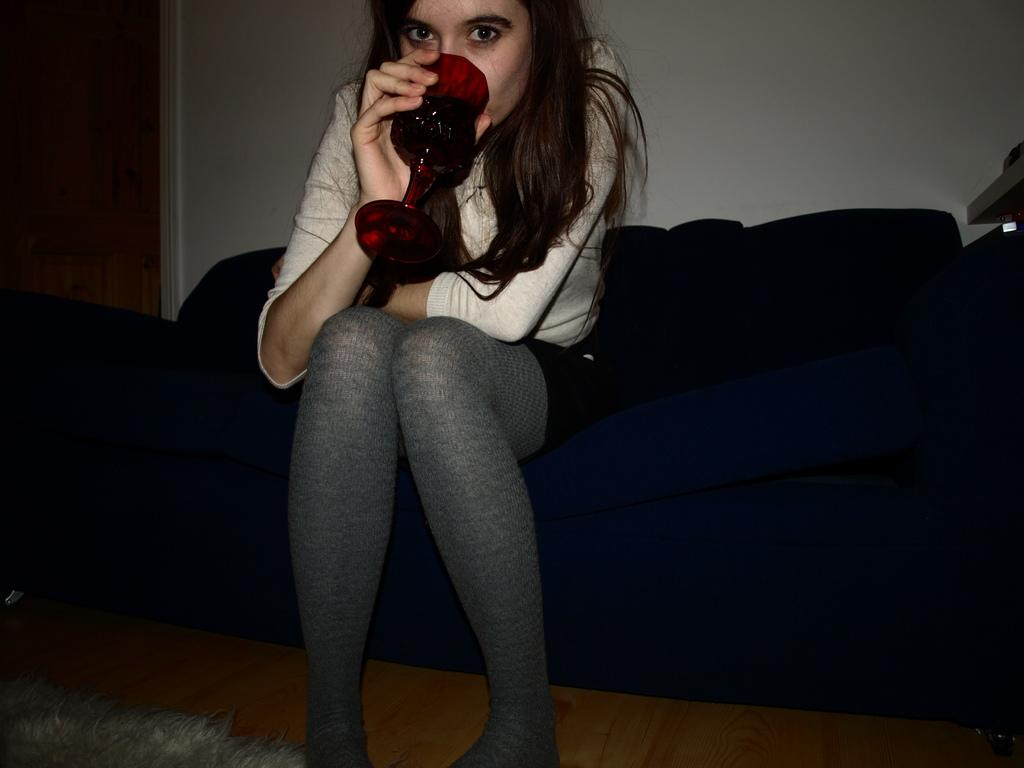Who is present in the image? There is a woman in the image. What is the woman doing in the image? The woman is seated on a sofa. What is the woman holding in her hand? The woman is holding a wine glass in her hand. How is the woman contributing to pollution in the image? There is no indication of pollution in the image, and the woman's actions do not suggest any contribution to pollution. 